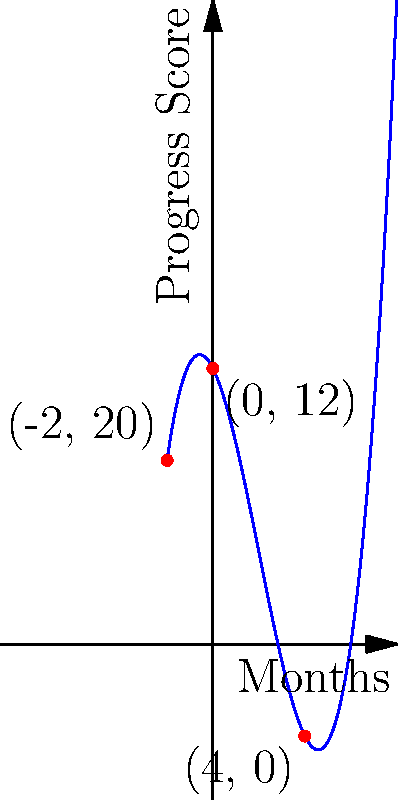A child's progress in occupational therapy is modeled by the polynomial function $f(x) = 0.25x^3 - 1.5x^2 - 2x + 12$, where $x$ represents months in therapy and $f(x)$ represents the progress score. Analyze the graph and determine the root that represents when the child's progress score reaches zero. What does this root signify in the context of the child's therapy? To solve this problem, let's follow these steps:

1) The roots of a polynomial function are the x-values where the function crosses the x-axis, i.e., where $f(x) = 0$.

2) From the graph, we can see that the function crosses the x-axis at one point.

3) This point of intersection appears to be at (4, 0).

4) To verify, we can substitute x = 4 into the original function:

   $f(4) = 0.25(4)^3 - 1.5(4)^2 - 2(4) + 12$
         $= 0.25(64) - 1.5(16) - 8 + 12$
         $= 16 - 24 - 8 + 12$
         $= -4 + 12$
         $= 0$

5) This confirms that x = 4 is indeed a root of the function.

6) In the context of the child's therapy, this root signifies that after 4 months of therapy, the child's progress score reaches zero.

7) However, it's important to note that a score of zero doesn't necessarily mean no progress. In this model, it could represent reaching a baseline or target level set at the beginning of therapy.
Answer: The root at x = 4 signifies that the child's progress score reaches the target level after 4 months of therapy. 